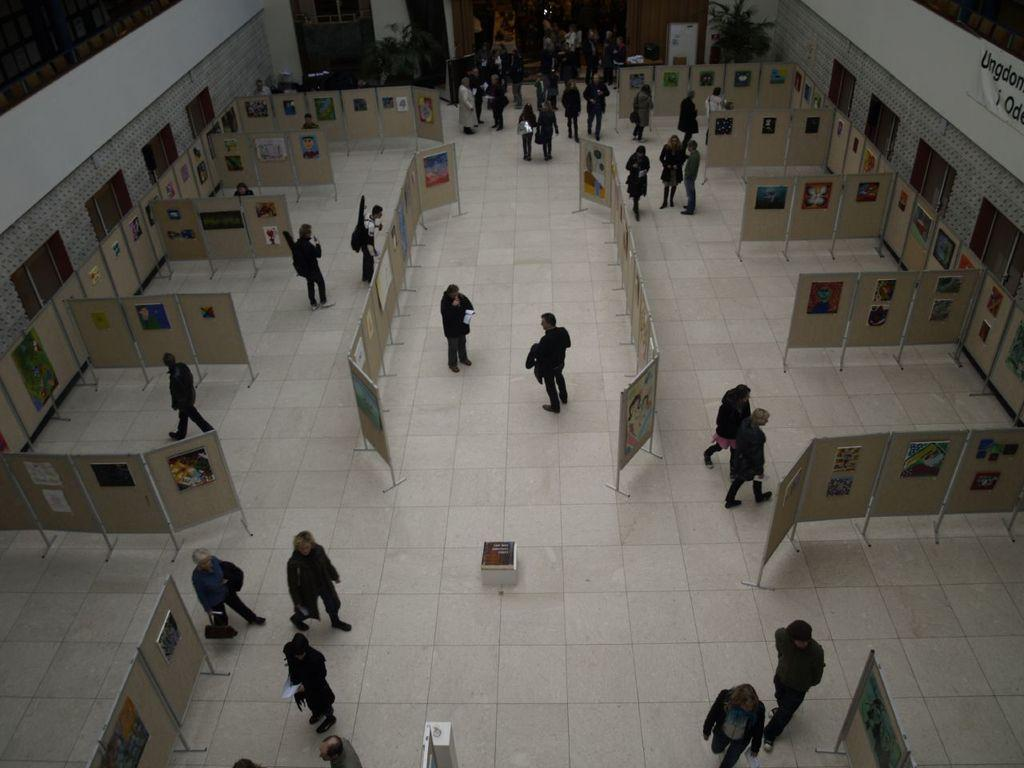How many people are in the image? There are many people in the image. What is visible at the bottom of the image? There is a floor visible at the bottom of the image. Where was the image likely taken? The image appears to be taken inside a building. What objects can be seen in the image besides people? There are boards present in the image. Can you see a boat in the image? No, there is no boat present in the image. What type of pipe is visible in the image? There is no pipe present in the image. 